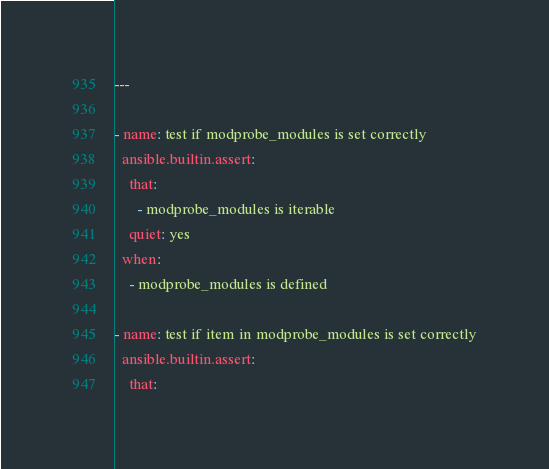Convert code to text. <code><loc_0><loc_0><loc_500><loc_500><_YAML_>---

- name: test if modprobe_modules is set correctly
  ansible.builtin.assert:
    that:
      - modprobe_modules is iterable
    quiet: yes
  when:
    - modprobe_modules is defined

- name: test if item in modprobe_modules is set correctly
  ansible.builtin.assert:
    that:</code> 